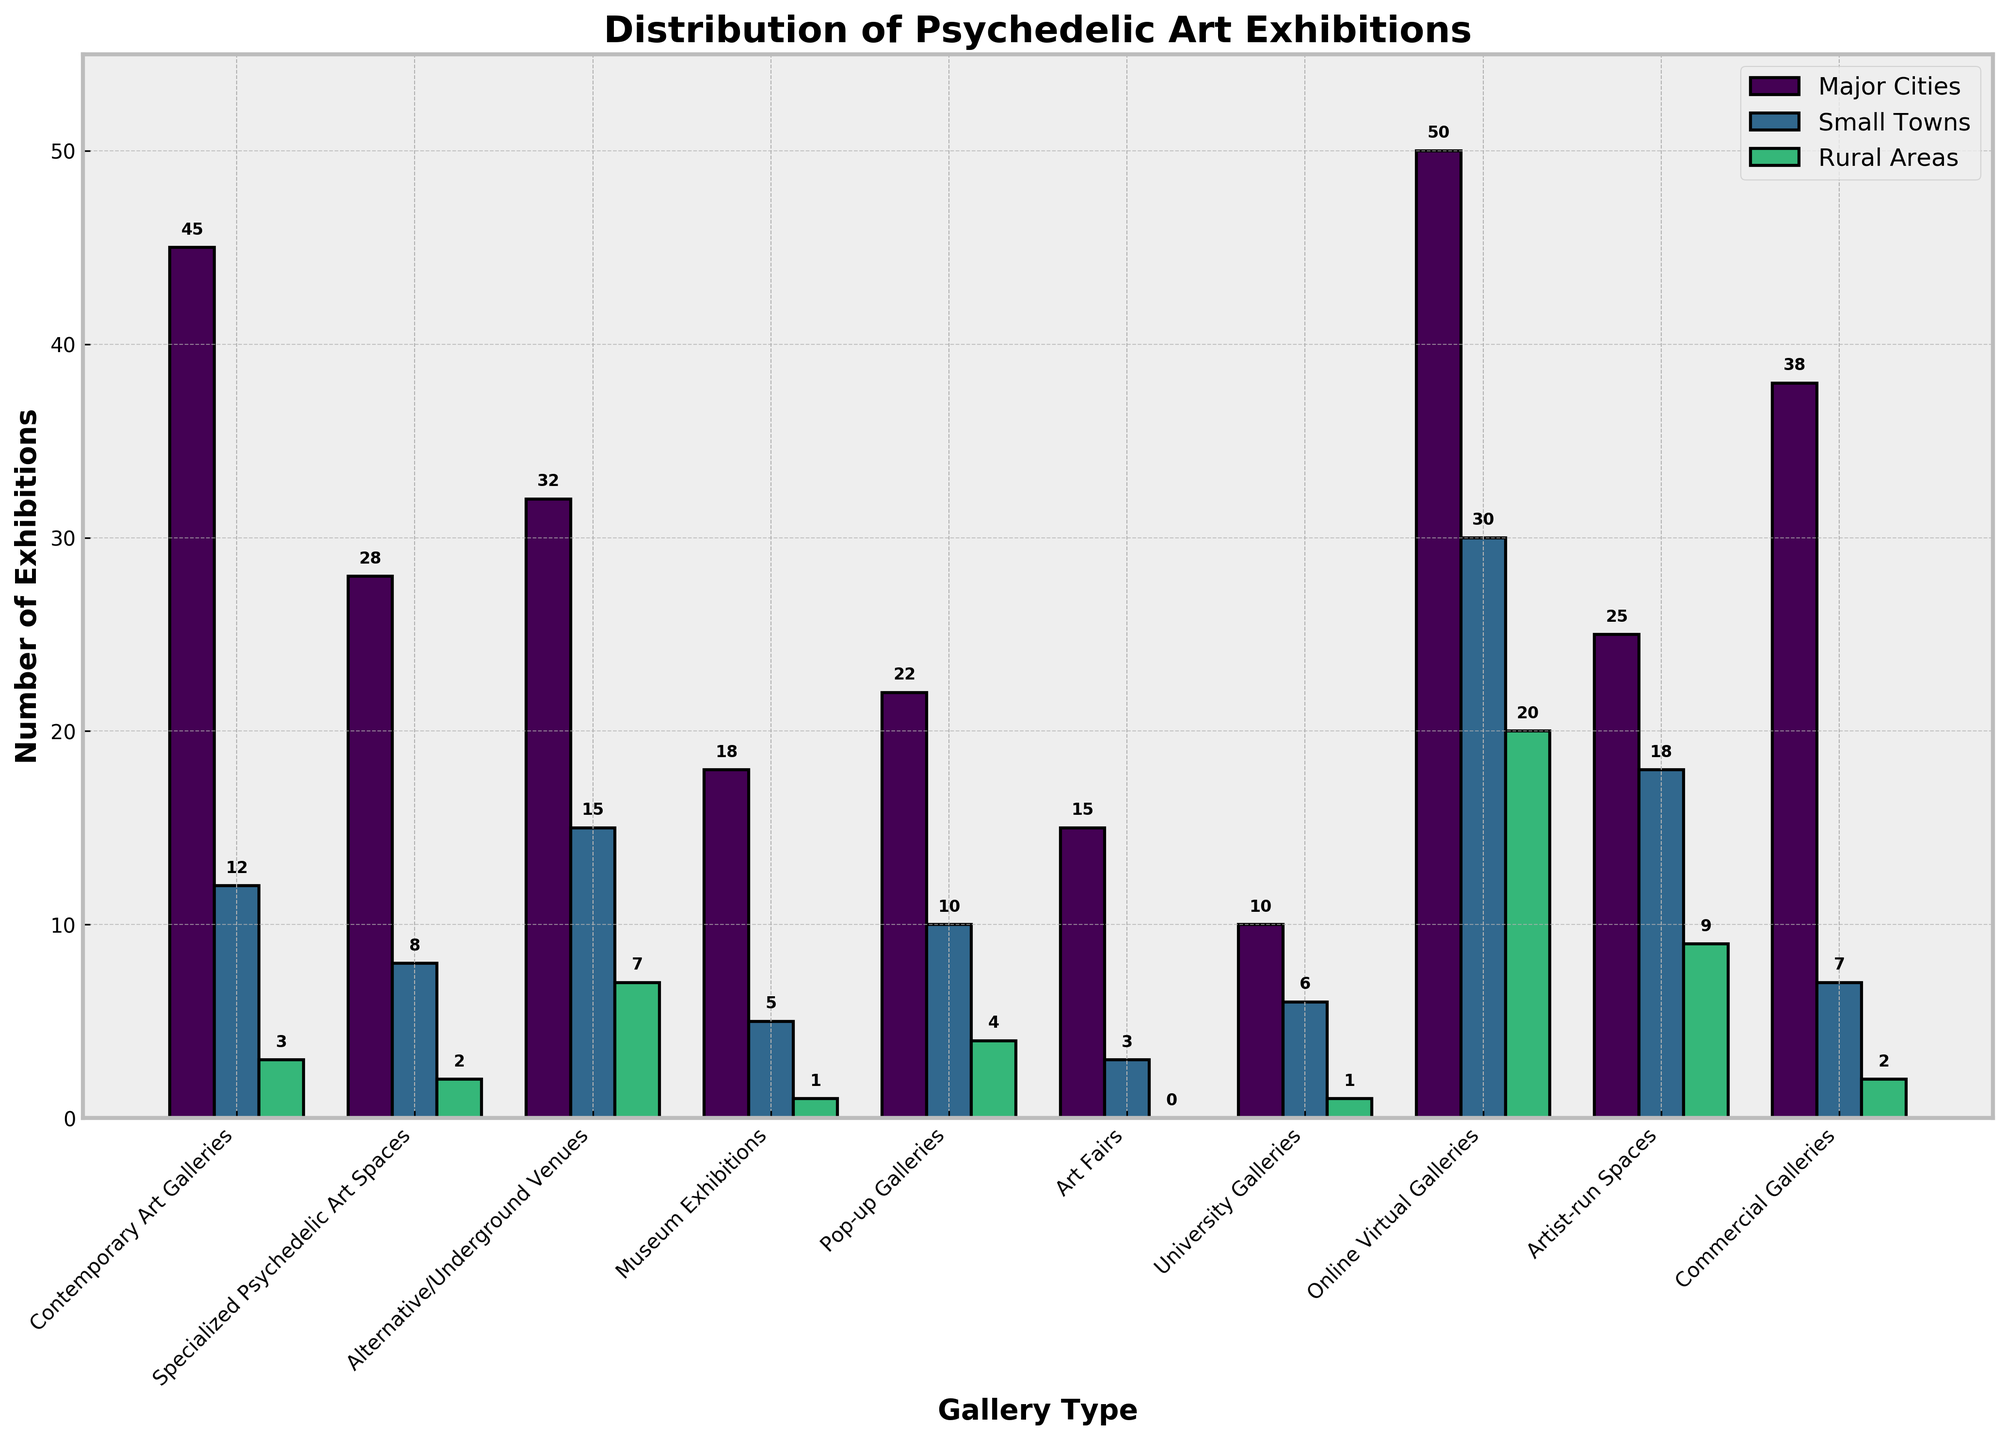What is the total number of exhibitions in Contemporary Art Galleries across all locations? Look at the values for Contemporary Art Galleries in Major Cities, Small Towns, and Rural Areas, which are 45, 12, and 3 respectively. Adding them together: 45 + 12 + 3 = 60
Answer: 60 Which gallery type has the highest number of exhibitions in Major Cities? Observe the heights of the bars corresponding to Major Cities. Online Virtual Galleries have the tallest bar with 50 exhibitions in Major Cities
Answer: Online Virtual Galleries How many more exhibitions are there in Specialized Psychedelic Art Spaces in Major Cities compared to Small Towns? Identify the values for Specialized Psychedelic Art Spaces in Major Cities (28) and Small Towns (8). Calculate the difference: 28 - 8 = 20
Answer: 20 Which gallery type has the fewest exhibitions in Rural Areas? Find the shortest bar in the Rural Areas category which corresponds to Art Fairs with 0 exhibitions
Answer: Art Fairs Compare the total number of exhibitions in Pop-up Galleries and Artist-run Spaces. Which has more and by how much? Add the values for Pop-up Galleries (22 in Major Cities, 10 in Small Towns, 4 in Rural Areas) and Artist-run Spaces (25 in Major Cities, 18 in Small Towns, 9 in Rural Areas). Totals are 22 + 10 + 4 = 36 and 25 + 18 + 9 = 52 respectively. Then compare: 52 - 36 = 16, Artist-run Spaces has more
Answer: Artist-run Spaces by 16 What is the average number of exhibitions for Museum Exhibitions across all locations? Sum the exhibitions for Museum Exhibitions in Major Cities, Small Towns, and Rural Areas which are 18, 5, and 1 respectively. Then find the average: (18 + 5 + 1) / 3 = 24 / 3 = 8
Answer: 8 Among University Galleries and Commercial Galleries, which has a higher number of exhibitions in Small Towns, and by what number? Compare the values in Small Towns for both gallery types: University Galleries (6) and Commercial Galleries (7). The difference is: 7 - 6 = 1, so Commercial Galleries has 1 more
Answer: Commercial Galleries by 1 How many more total exhibitions are there in Alternative/Underground Venues compared to Art Fairs across all locations? Add the values for Alternative/Underground Venues (32 in Major Cities, 15 in Small Towns, 7 in Rural Areas) and Art Fairs (15 in Major Cities, 3 in Small Towns, 0 in Rural Areas). Totals are 32 + 15 + 7 = 54 and 15 + 3 = 18. The difference: 54 - 18 = 36
Answer: 36 What proportion of the total exhibitions for Online Virtual Galleries occurs in Rural Areas? The total number for Online Virtual Galleries across all locations is 50 (Major Cities) + 30 (Small Towns) + 20 (Rural Areas) = 100. The proportion for Rural Areas is 20/100 = 0.2 or 20%
Answer: 20% 